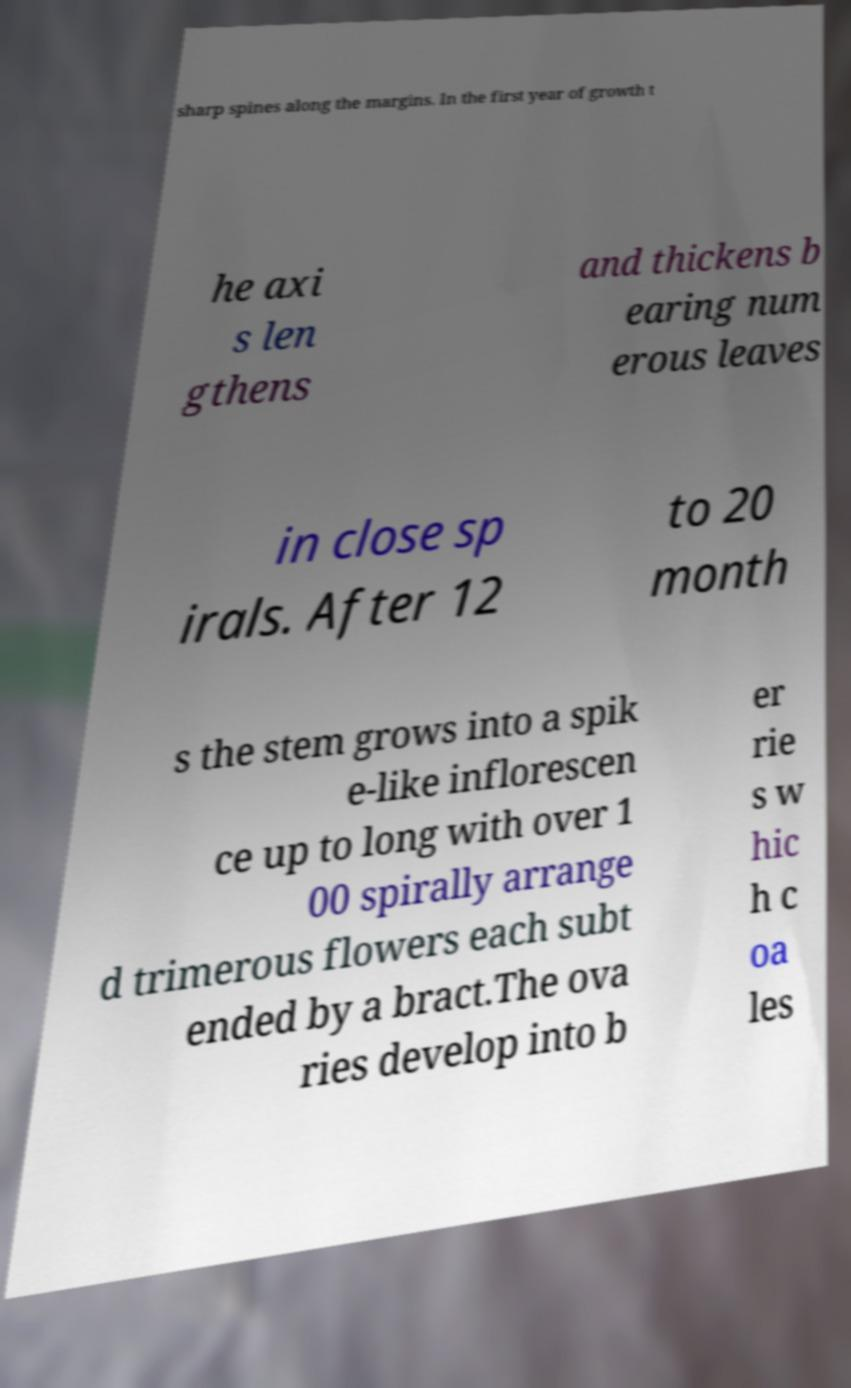There's text embedded in this image that I need extracted. Can you transcribe it verbatim? sharp spines along the margins. In the first year of growth t he axi s len gthens and thickens b earing num erous leaves in close sp irals. After 12 to 20 month s the stem grows into a spik e-like inflorescen ce up to long with over 1 00 spirally arrange d trimerous flowers each subt ended by a bract.The ova ries develop into b er rie s w hic h c oa les 